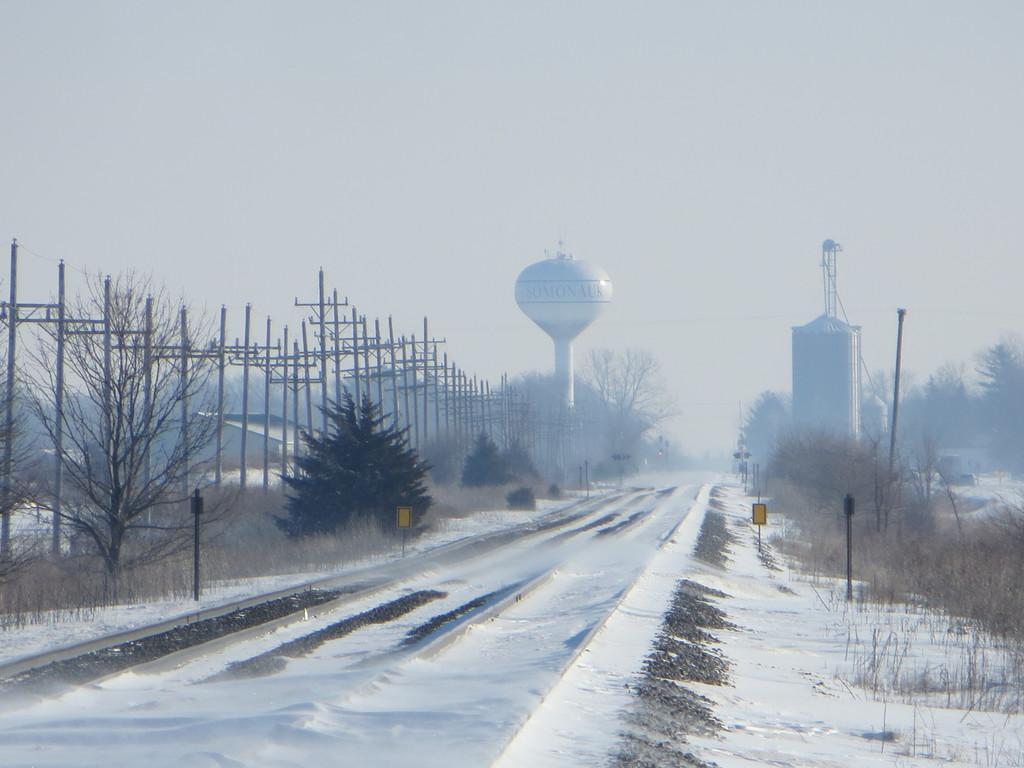Could you give a brief overview of what you see in this image? In the image we can see there is a ground covered with snow and there are trees and there are buildings. 